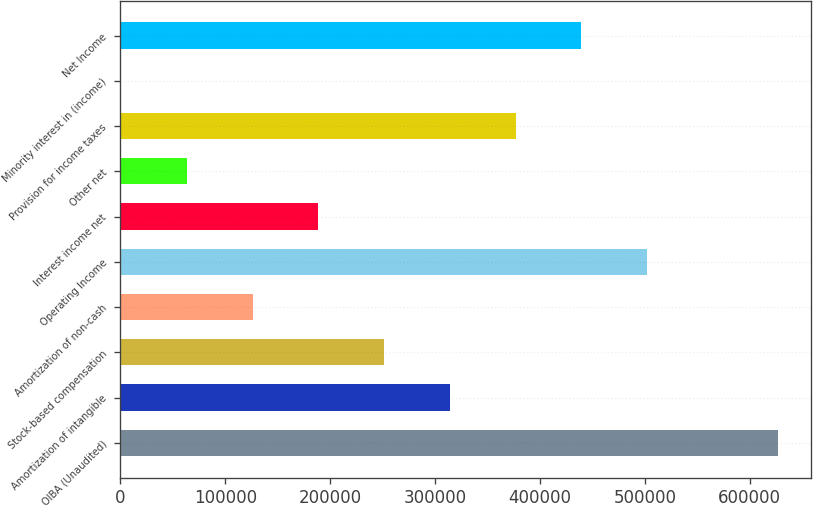Convert chart to OTSL. <chart><loc_0><loc_0><loc_500><loc_500><bar_chart><fcel>OIBA (Unaudited)<fcel>Amortization of intangible<fcel>Stock-based compensation<fcel>Amortization of non-cash<fcel>Operating Income<fcel>Interest income net<fcel>Other net<fcel>Provision for income taxes<fcel>Minority interest in (income)<fcel>Net Income<nl><fcel>627441<fcel>314138<fcel>251478<fcel>126157<fcel>502120<fcel>188818<fcel>63496.5<fcel>376799<fcel>836<fcel>439460<nl></chart> 